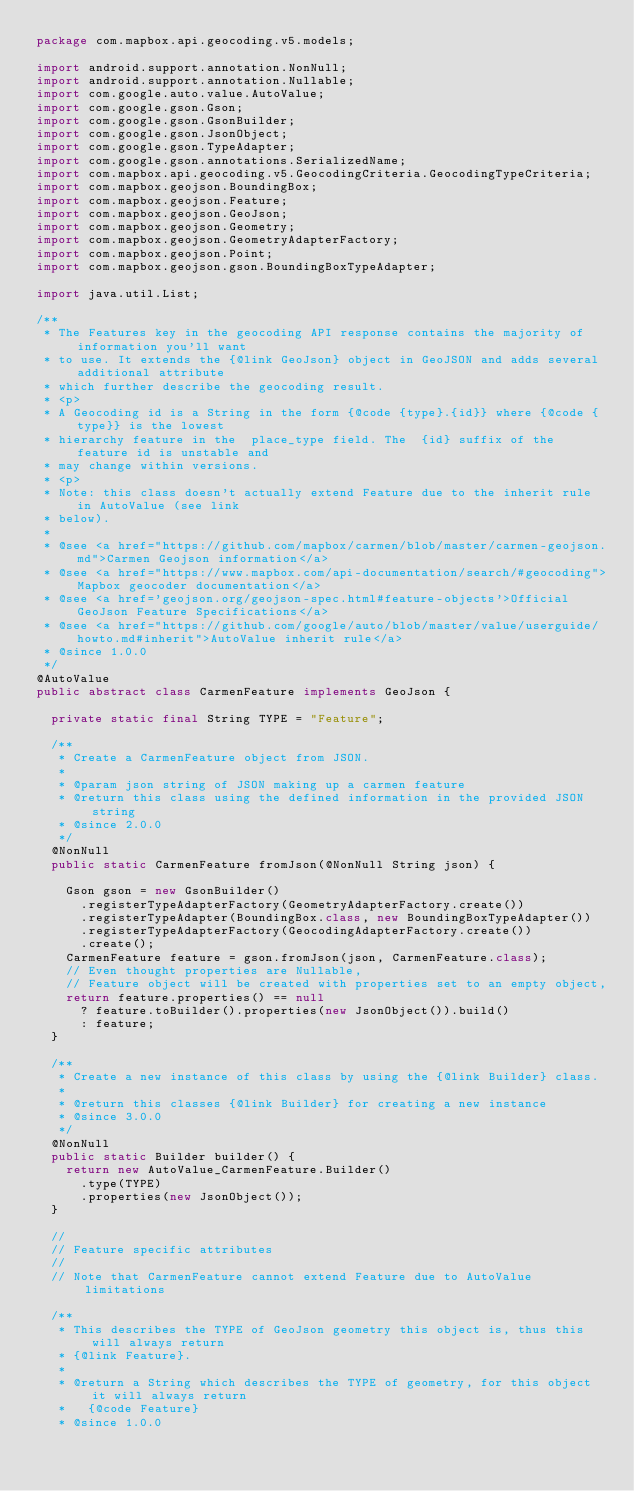Convert code to text. <code><loc_0><loc_0><loc_500><loc_500><_Java_>package com.mapbox.api.geocoding.v5.models;

import android.support.annotation.NonNull;
import android.support.annotation.Nullable;
import com.google.auto.value.AutoValue;
import com.google.gson.Gson;
import com.google.gson.GsonBuilder;
import com.google.gson.JsonObject;
import com.google.gson.TypeAdapter;
import com.google.gson.annotations.SerializedName;
import com.mapbox.api.geocoding.v5.GeocodingCriteria.GeocodingTypeCriteria;
import com.mapbox.geojson.BoundingBox;
import com.mapbox.geojson.Feature;
import com.mapbox.geojson.GeoJson;
import com.mapbox.geojson.Geometry;
import com.mapbox.geojson.GeometryAdapterFactory;
import com.mapbox.geojson.Point;
import com.mapbox.geojson.gson.BoundingBoxTypeAdapter;

import java.util.List;

/**
 * The Features key in the geocoding API response contains the majority of information you'll want
 * to use. It extends the {@link GeoJson} object in GeoJSON and adds several additional attribute
 * which further describe the geocoding result.
 * <p>
 * A Geocoding id is a String in the form {@code {type}.{id}} where {@code {type}} is the lowest
 * hierarchy feature in the  place_type field. The  {id} suffix of the feature id is unstable and
 * may change within versions.
 * <p>
 * Note: this class doesn't actually extend Feature due to the inherit rule in AutoValue (see link
 * below).
 *
 * @see <a href="https://github.com/mapbox/carmen/blob/master/carmen-geojson.md">Carmen Geojson information</a>
 * @see <a href="https://www.mapbox.com/api-documentation/search/#geocoding">Mapbox geocoder documentation</a>
 * @see <a href='geojson.org/geojson-spec.html#feature-objects'>Official GeoJson Feature Specifications</a>
 * @see <a href="https://github.com/google/auto/blob/master/value/userguide/howto.md#inherit">AutoValue inherit rule</a>
 * @since 1.0.0
 */
@AutoValue
public abstract class CarmenFeature implements GeoJson {

  private static final String TYPE = "Feature";

  /**
   * Create a CarmenFeature object from JSON.
   *
   * @param json string of JSON making up a carmen feature
   * @return this class using the defined information in the provided JSON string
   * @since 2.0.0
   */
  @NonNull
  public static CarmenFeature fromJson(@NonNull String json) {

    Gson gson = new GsonBuilder()
      .registerTypeAdapterFactory(GeometryAdapterFactory.create())
      .registerTypeAdapter(BoundingBox.class, new BoundingBoxTypeAdapter())
      .registerTypeAdapterFactory(GeocodingAdapterFactory.create())
      .create();
    CarmenFeature feature = gson.fromJson(json, CarmenFeature.class);
    // Even thought properties are Nullable,
    // Feature object will be created with properties set to an empty object,
    return feature.properties() == null
      ? feature.toBuilder().properties(new JsonObject()).build()
      : feature;
  }

  /**
   * Create a new instance of this class by using the {@link Builder} class.
   *
   * @return this classes {@link Builder} for creating a new instance
   * @since 3.0.0
   */
  @NonNull
  public static Builder builder() {
    return new AutoValue_CarmenFeature.Builder()
      .type(TYPE)
      .properties(new JsonObject());
  }

  //
  // Feature specific attributes
  //
  // Note that CarmenFeature cannot extend Feature due to AutoValue limitations

  /**
   * This describes the TYPE of GeoJson geometry this object is, thus this will always return
   * {@link Feature}.
   *
   * @return a String which describes the TYPE of geometry, for this object it will always return
   *   {@code Feature}
   * @since 1.0.0</code> 